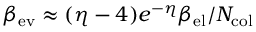Convert formula to latex. <formula><loc_0><loc_0><loc_500><loc_500>\beta _ { e v } \approx ( \eta - 4 ) e ^ { - \eta } \beta _ { e l } / N _ { c o l }</formula> 